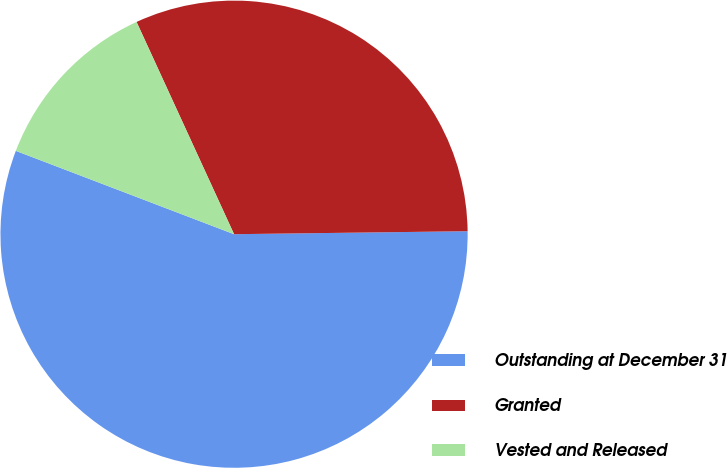Convert chart to OTSL. <chart><loc_0><loc_0><loc_500><loc_500><pie_chart><fcel>Outstanding at December 31<fcel>Granted<fcel>Vested and Released<nl><fcel>56.01%<fcel>31.65%<fcel>12.34%<nl></chart> 